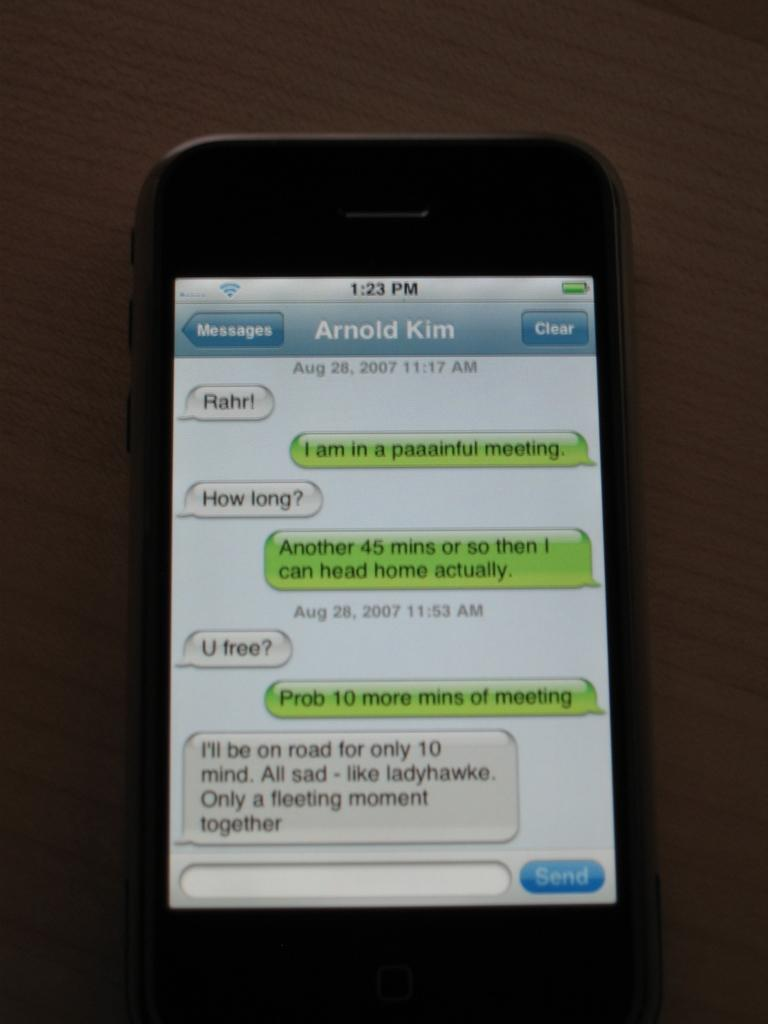<image>
Summarize the visual content of the image. Phone showing a conversation between Arnold Kim and another person. 